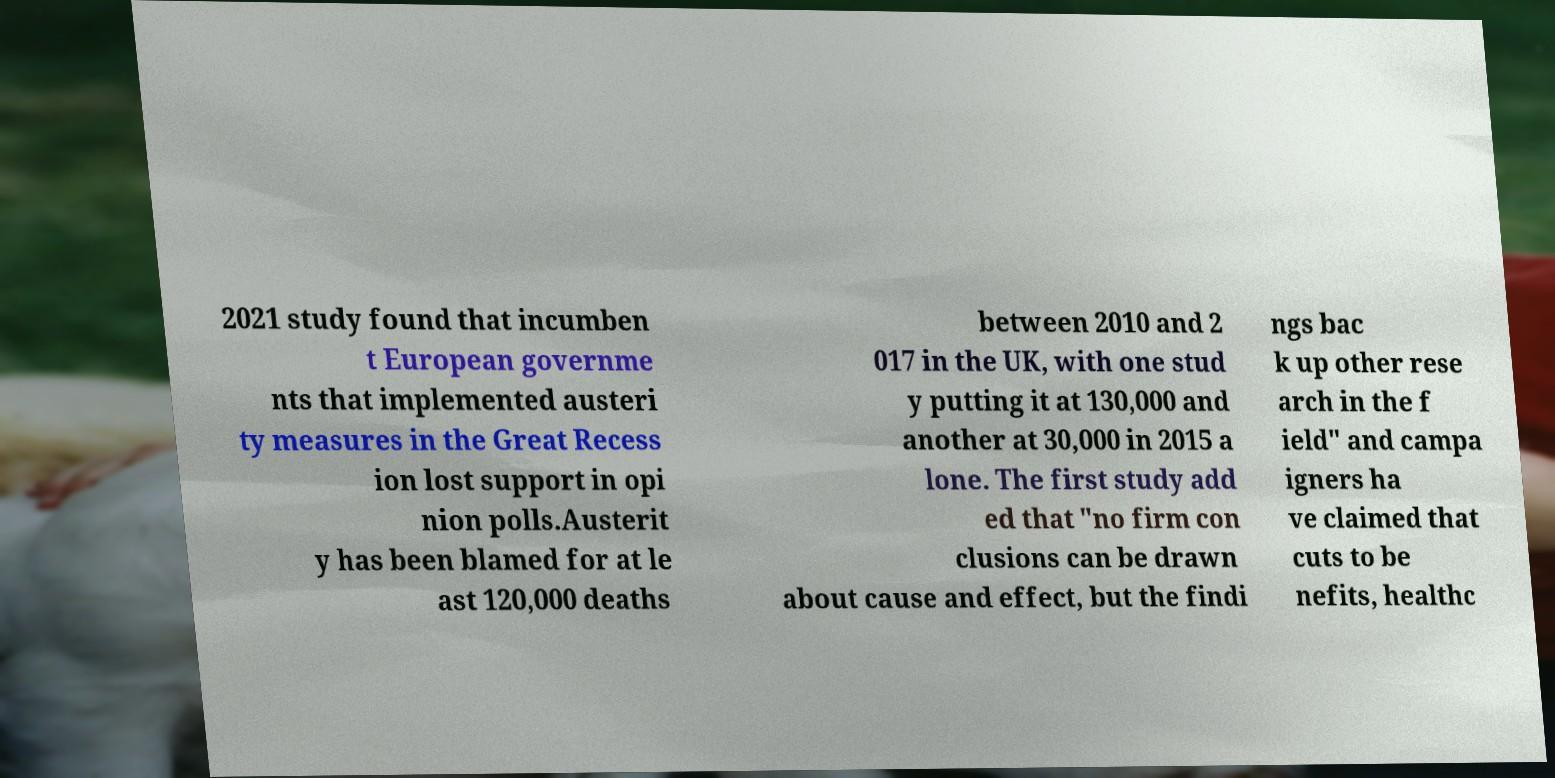I need the written content from this picture converted into text. Can you do that? 2021 study found that incumben t European governme nts that implemented austeri ty measures in the Great Recess ion lost support in opi nion polls.Austerit y has been blamed for at le ast 120,000 deaths between 2010 and 2 017 in the UK, with one stud y putting it at 130,000 and another at 30,000 in 2015 a lone. The first study add ed that "no firm con clusions can be drawn about cause and effect, but the findi ngs bac k up other rese arch in the f ield" and campa igners ha ve claimed that cuts to be nefits, healthc 